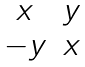<formula> <loc_0><loc_0><loc_500><loc_500>\begin{matrix} x & y \\ - y & x \\ \end{matrix}</formula> 